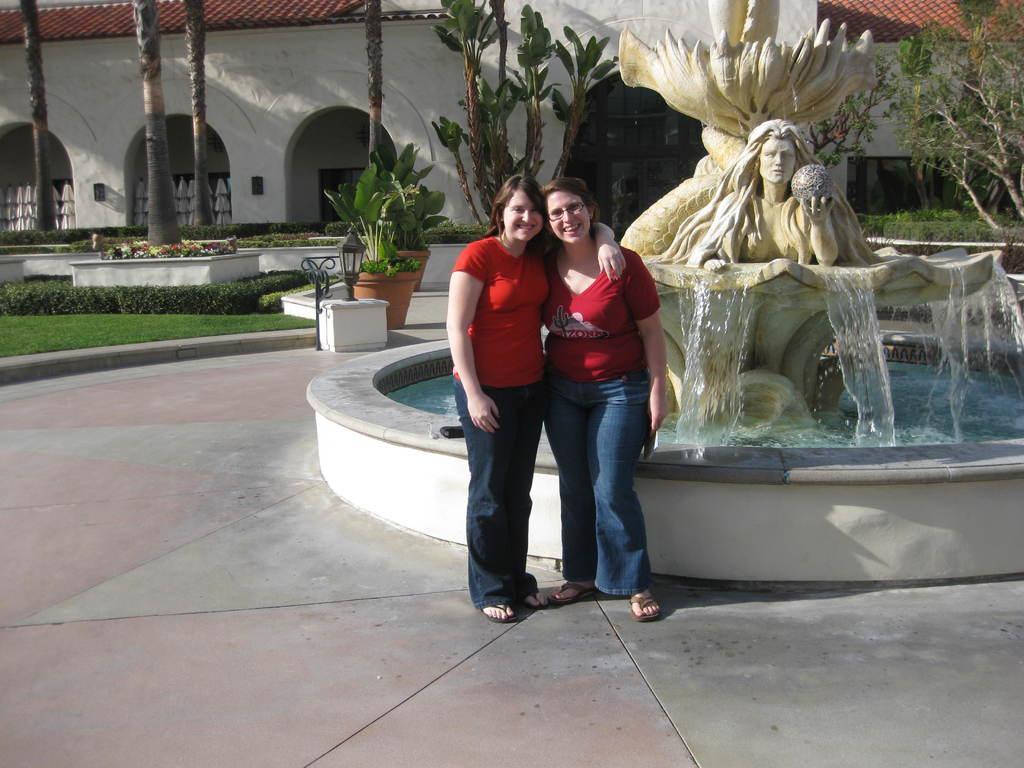Please provide a concise description of this image. In this image we can see two lady persons wearing red color T-shirt standing on floor near the water fountain and in the background of the image there are some plants, trees, grass and there is a house. 